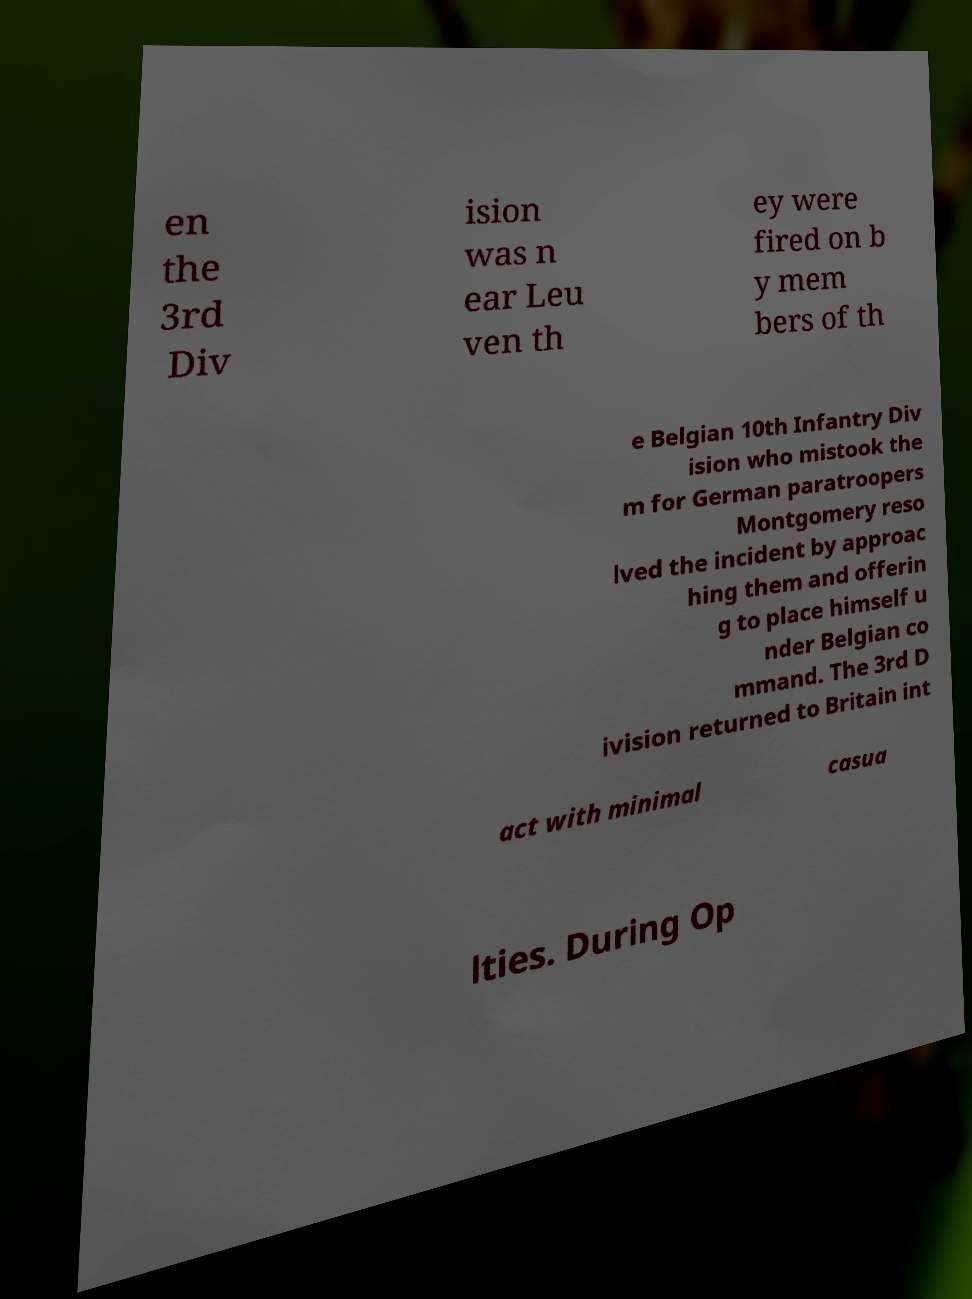Can you read and provide the text displayed in the image?This photo seems to have some interesting text. Can you extract and type it out for me? en the 3rd Div ision was n ear Leu ven th ey were fired on b y mem bers of th e Belgian 10th Infantry Div ision who mistook the m for German paratroopers Montgomery reso lved the incident by approac hing them and offerin g to place himself u nder Belgian co mmand. The 3rd D ivision returned to Britain int act with minimal casua lties. During Op 